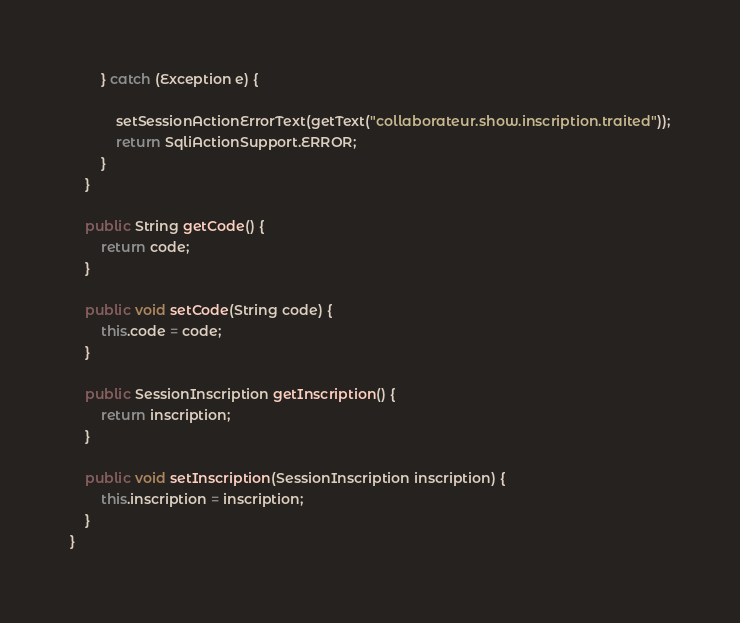<code> <loc_0><loc_0><loc_500><loc_500><_Java_>		} catch (Exception e) {
			
			setSessionActionErrorText(getText("collaborateur.show.inscription.traited"));
			return SqliActionSupport.ERROR;
		}
	}

	public String getCode() {
		return code;
	}

	public void setCode(String code) {
		this.code = code;
	}

	public SessionInscription getInscription() {
		return inscription;
	}

	public void setInscription(SessionInscription inscription) {
		this.inscription = inscription;
	}
}
</code> 